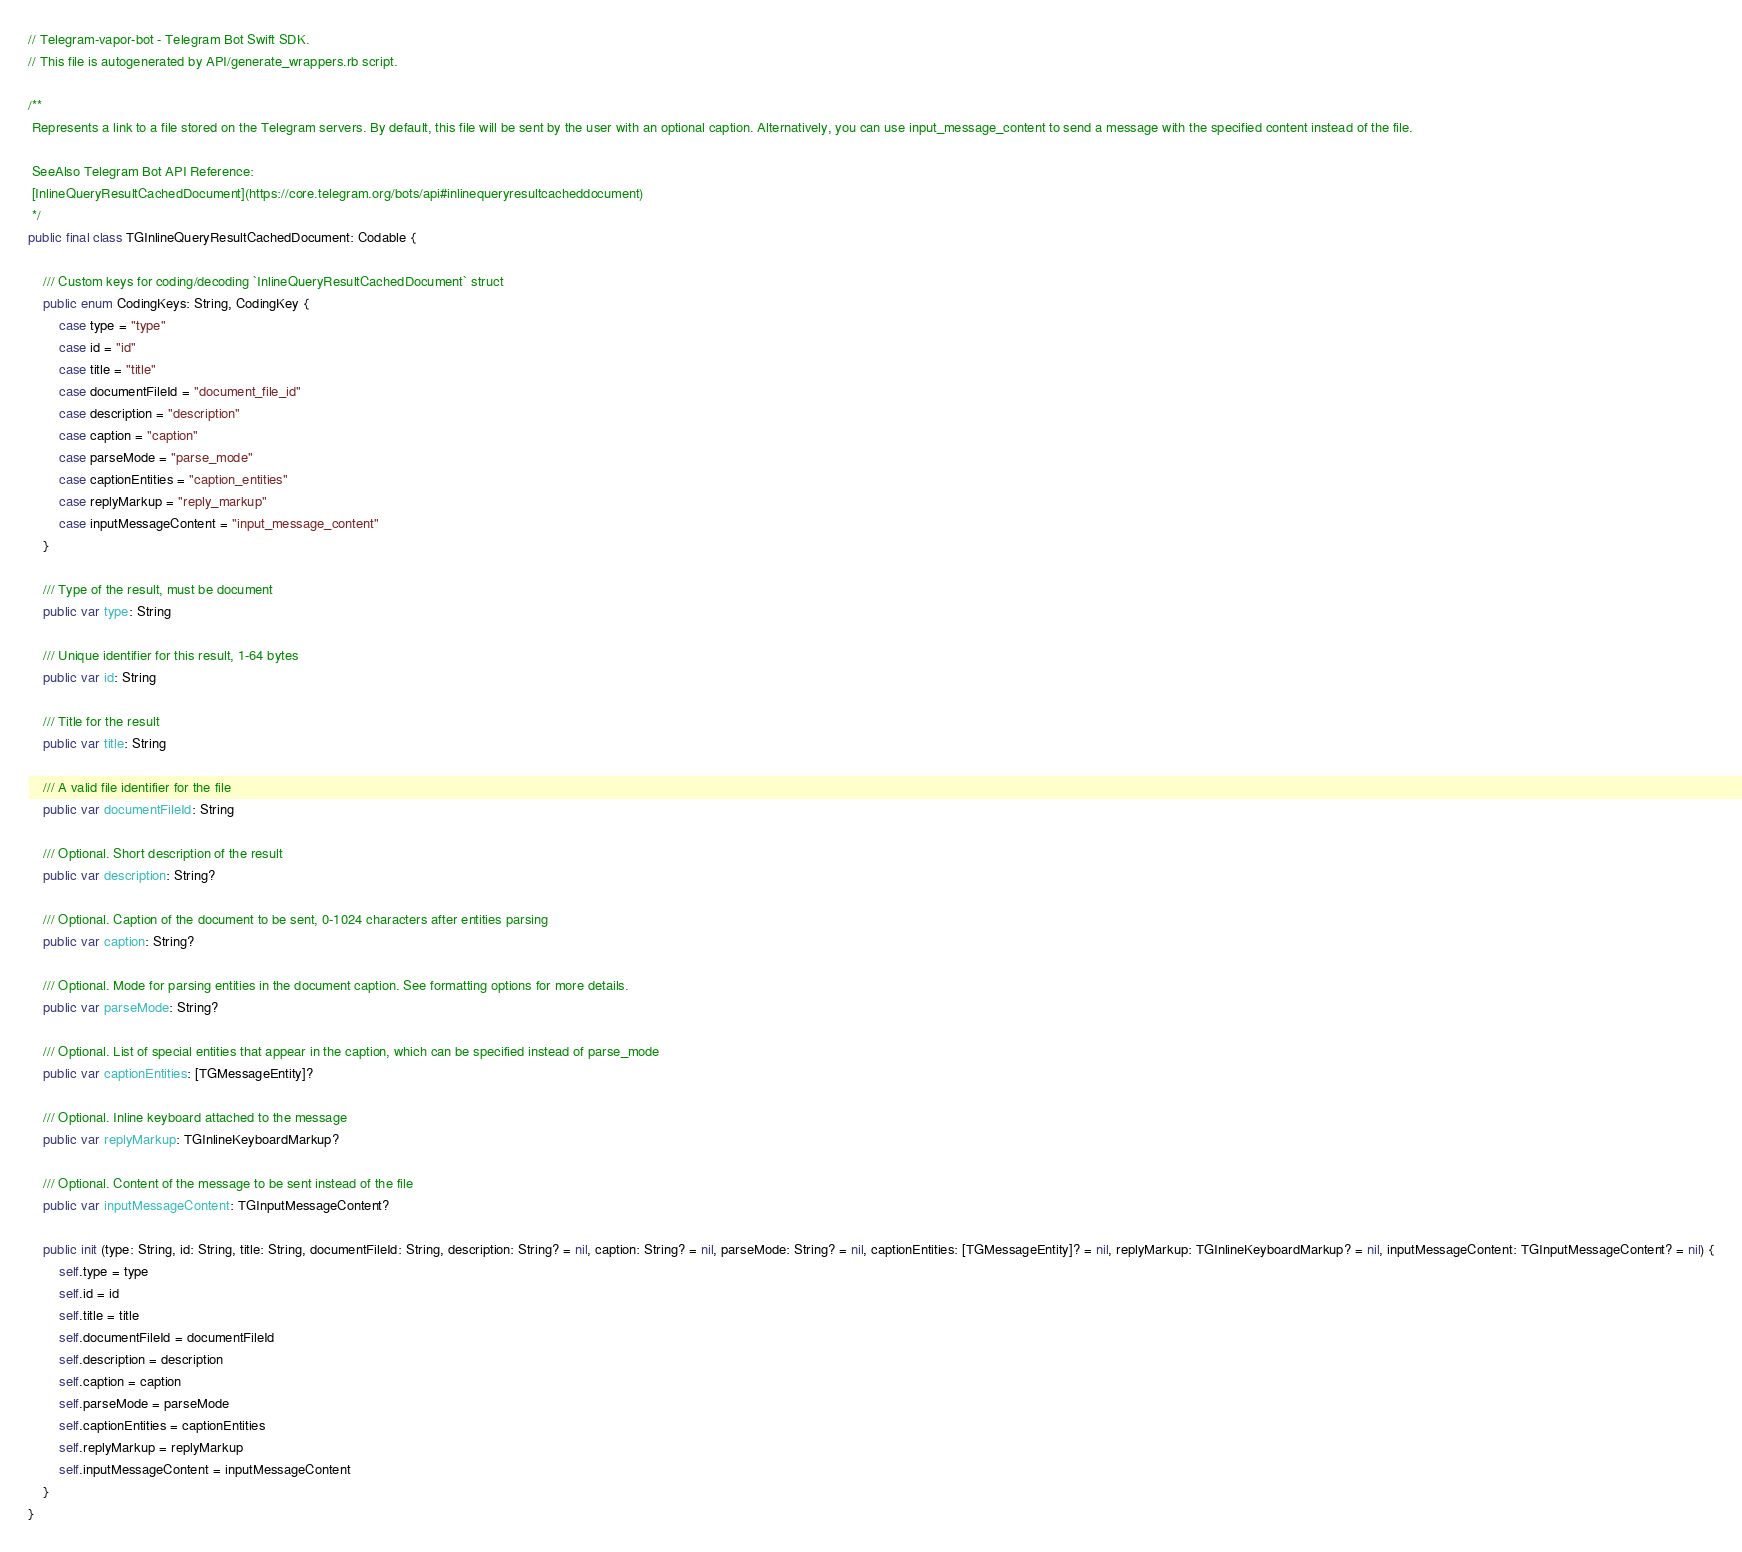<code> <loc_0><loc_0><loc_500><loc_500><_Swift_>// Telegram-vapor-bot - Telegram Bot Swift SDK.
// This file is autogenerated by API/generate_wrappers.rb script.

/**
 Represents a link to a file stored on the Telegram servers. By default, this file will be sent by the user with an optional caption. Alternatively, you can use input_message_content to send a message with the specified content instead of the file.

 SeeAlso Telegram Bot API Reference:
 [InlineQueryResultCachedDocument](https://core.telegram.org/bots/api#inlinequeryresultcacheddocument)
 */
public final class TGInlineQueryResultCachedDocument: Codable {

    /// Custom keys for coding/decoding `InlineQueryResultCachedDocument` struct
    public enum CodingKeys: String, CodingKey {
        case type = "type"
        case id = "id"
        case title = "title"
        case documentFileId = "document_file_id"
        case description = "description"
        case caption = "caption"
        case parseMode = "parse_mode"
        case captionEntities = "caption_entities"
        case replyMarkup = "reply_markup"
        case inputMessageContent = "input_message_content"
    }

    /// Type of the result, must be document
    public var type: String

    /// Unique identifier for this result, 1-64 bytes
    public var id: String

    /// Title for the result
    public var title: String

    /// A valid file identifier for the file
    public var documentFileId: String

    /// Optional. Short description of the result
    public var description: String?

    /// Optional. Caption of the document to be sent, 0-1024 characters after entities parsing
    public var caption: String?

    /// Optional. Mode for parsing entities in the document caption. See formatting options for more details.
    public var parseMode: String?

    /// Optional. List of special entities that appear in the caption, which can be specified instead of parse_mode
    public var captionEntities: [TGMessageEntity]?

    /// Optional. Inline keyboard attached to the message
    public var replyMarkup: TGInlineKeyboardMarkup?

    /// Optional. Content of the message to be sent instead of the file
    public var inputMessageContent: TGInputMessageContent?

    public init (type: String, id: String, title: String, documentFileId: String, description: String? = nil, caption: String? = nil, parseMode: String? = nil, captionEntities: [TGMessageEntity]? = nil, replyMarkup: TGInlineKeyboardMarkup? = nil, inputMessageContent: TGInputMessageContent? = nil) {
        self.type = type
        self.id = id
        self.title = title
        self.documentFileId = documentFileId
        self.description = description
        self.caption = caption
        self.parseMode = parseMode
        self.captionEntities = captionEntities
        self.replyMarkup = replyMarkup
        self.inputMessageContent = inputMessageContent
    }
}
</code> 